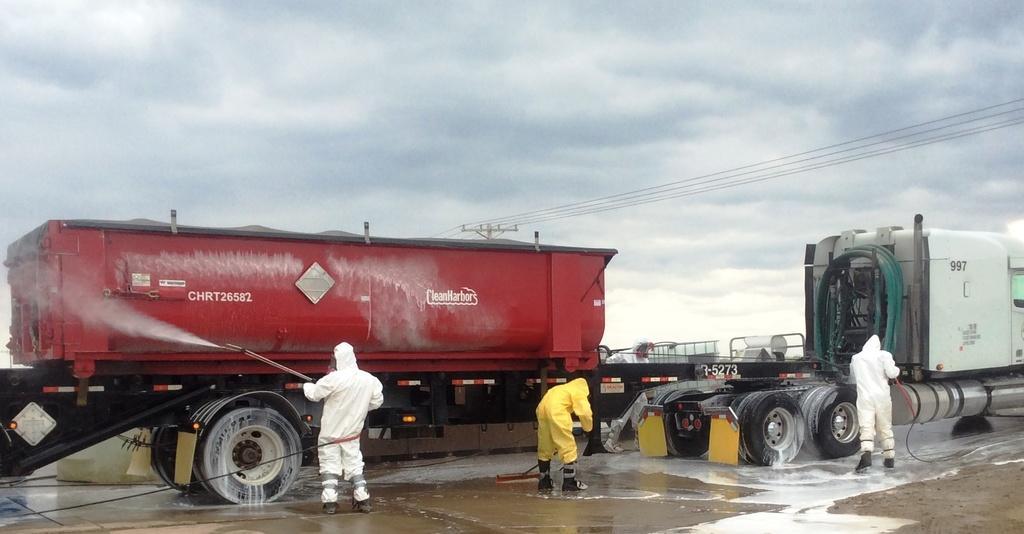Can you describe this image briefly? In this picture there is a man who is wearing a white dress and shoes. He is holding a water pipe. In front of him I can see the red color trucks. Beside him there is another man who is wearing yellow dress and shoes. On the right there is another man who is wearing standing near to the wheels. In the back I can see the fencing, poles, street pole, electric wires and other objects. At the top I can see the sky and clouds. 